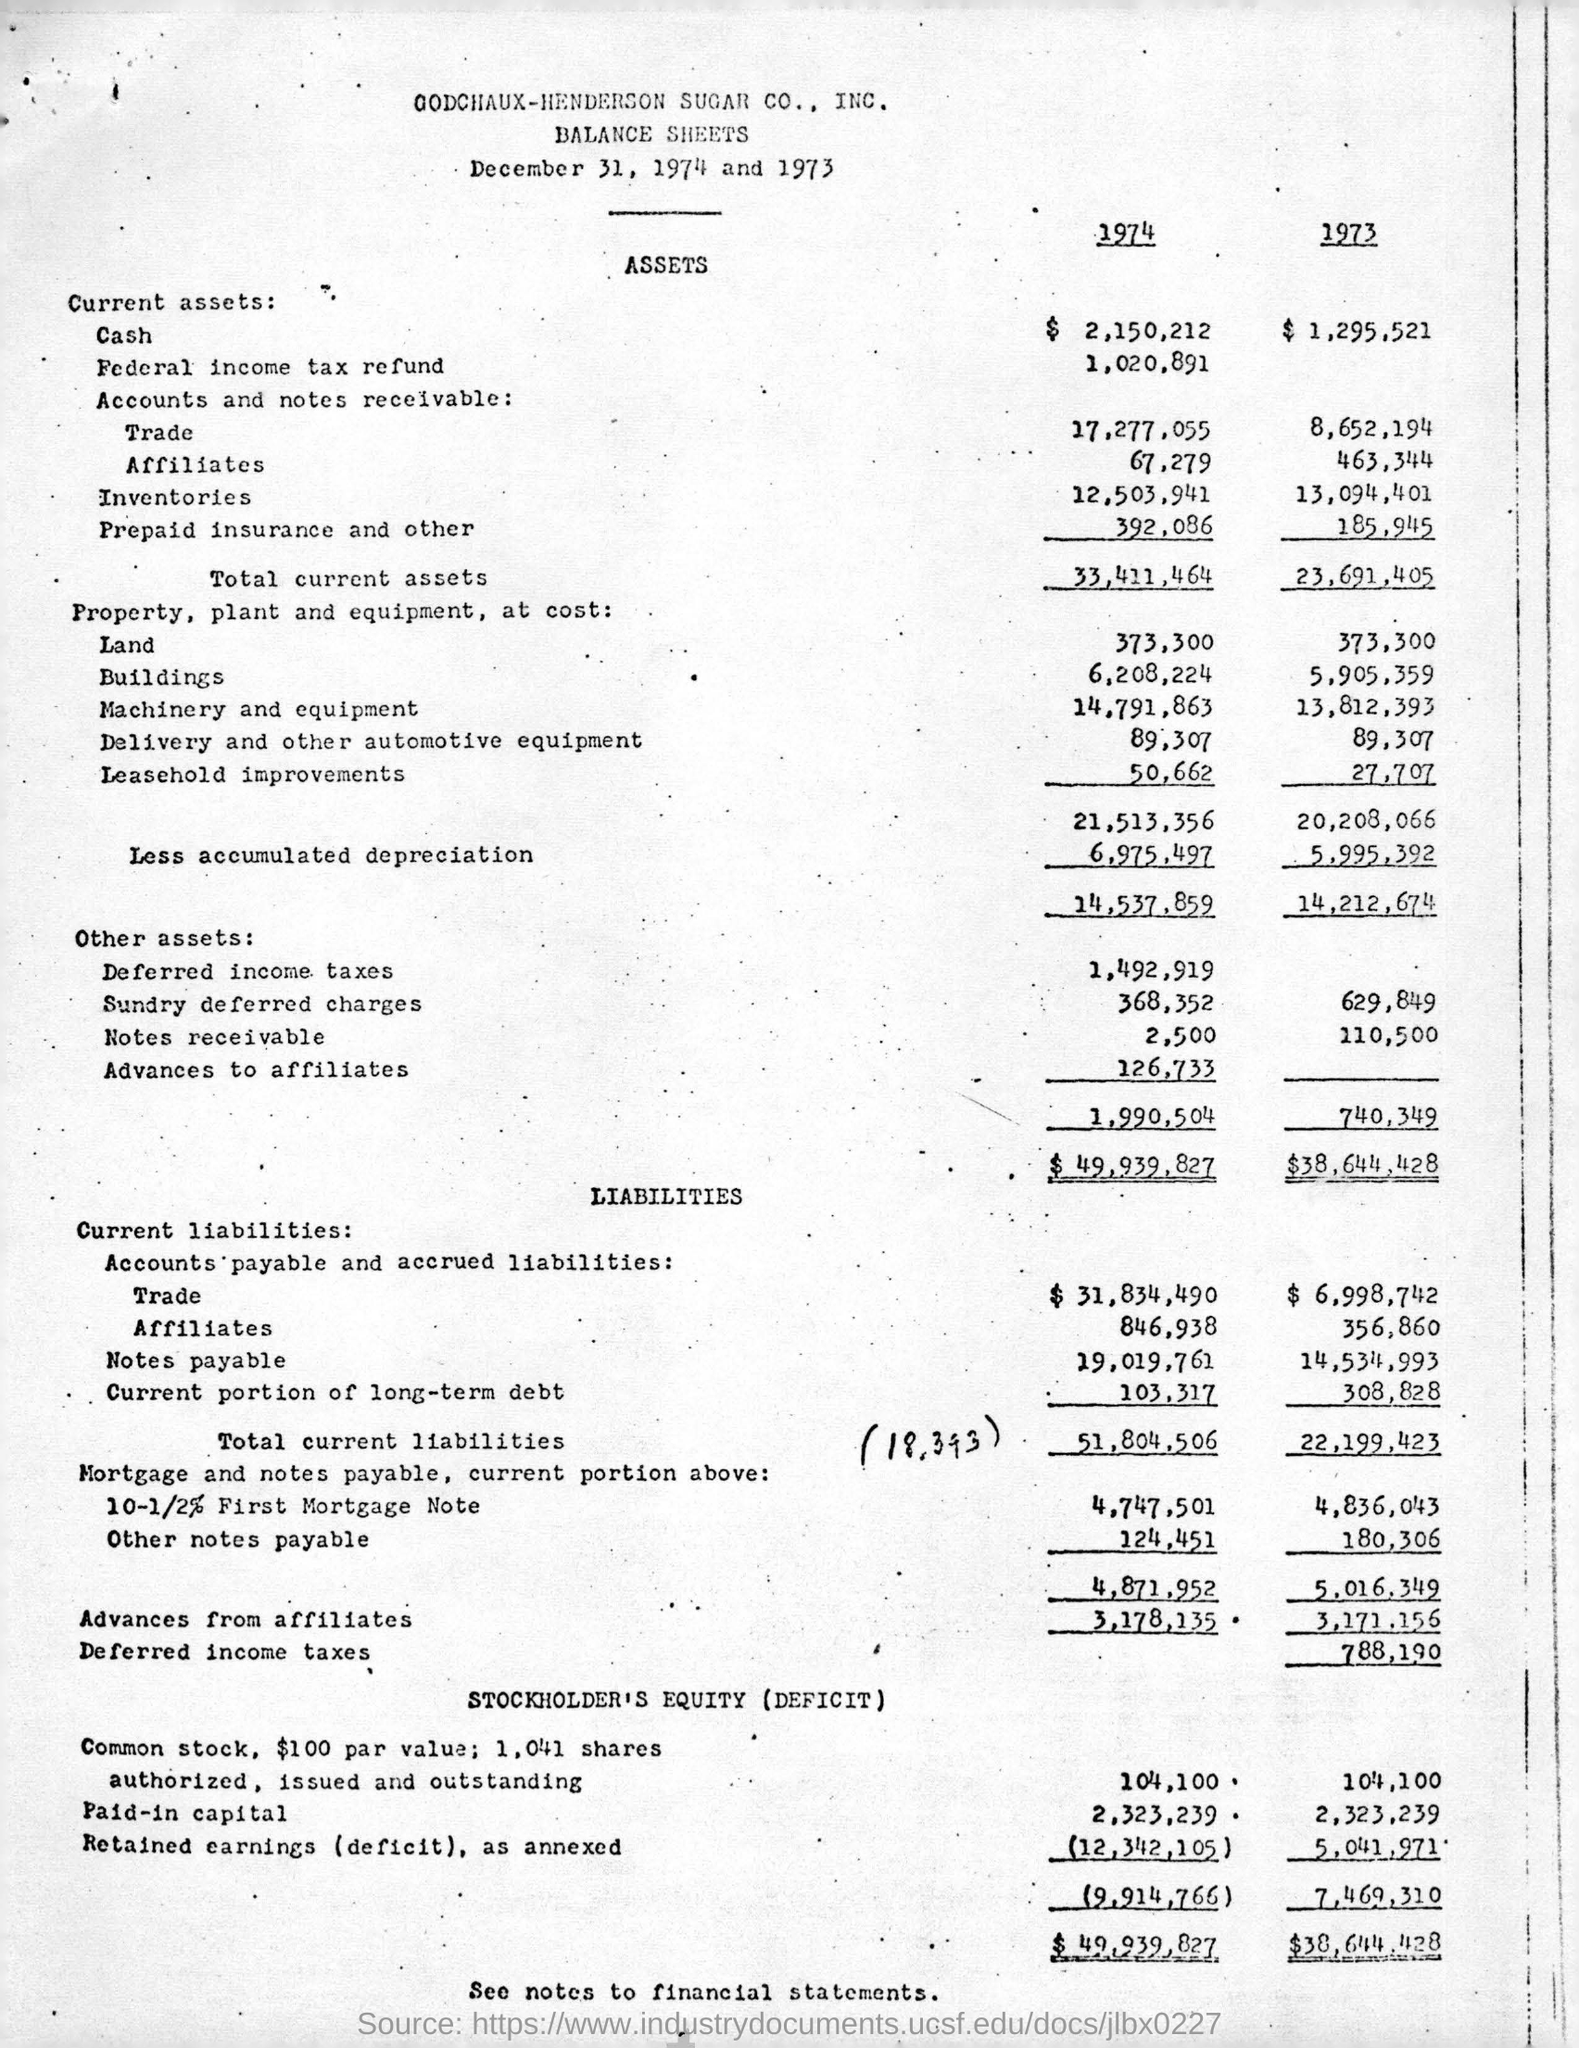Highlight a few significant elements in this photo. On the date of December 31, 1974, and 1973, it is noted that the date is specified. In 1973, the total assets were $38,644,428. 